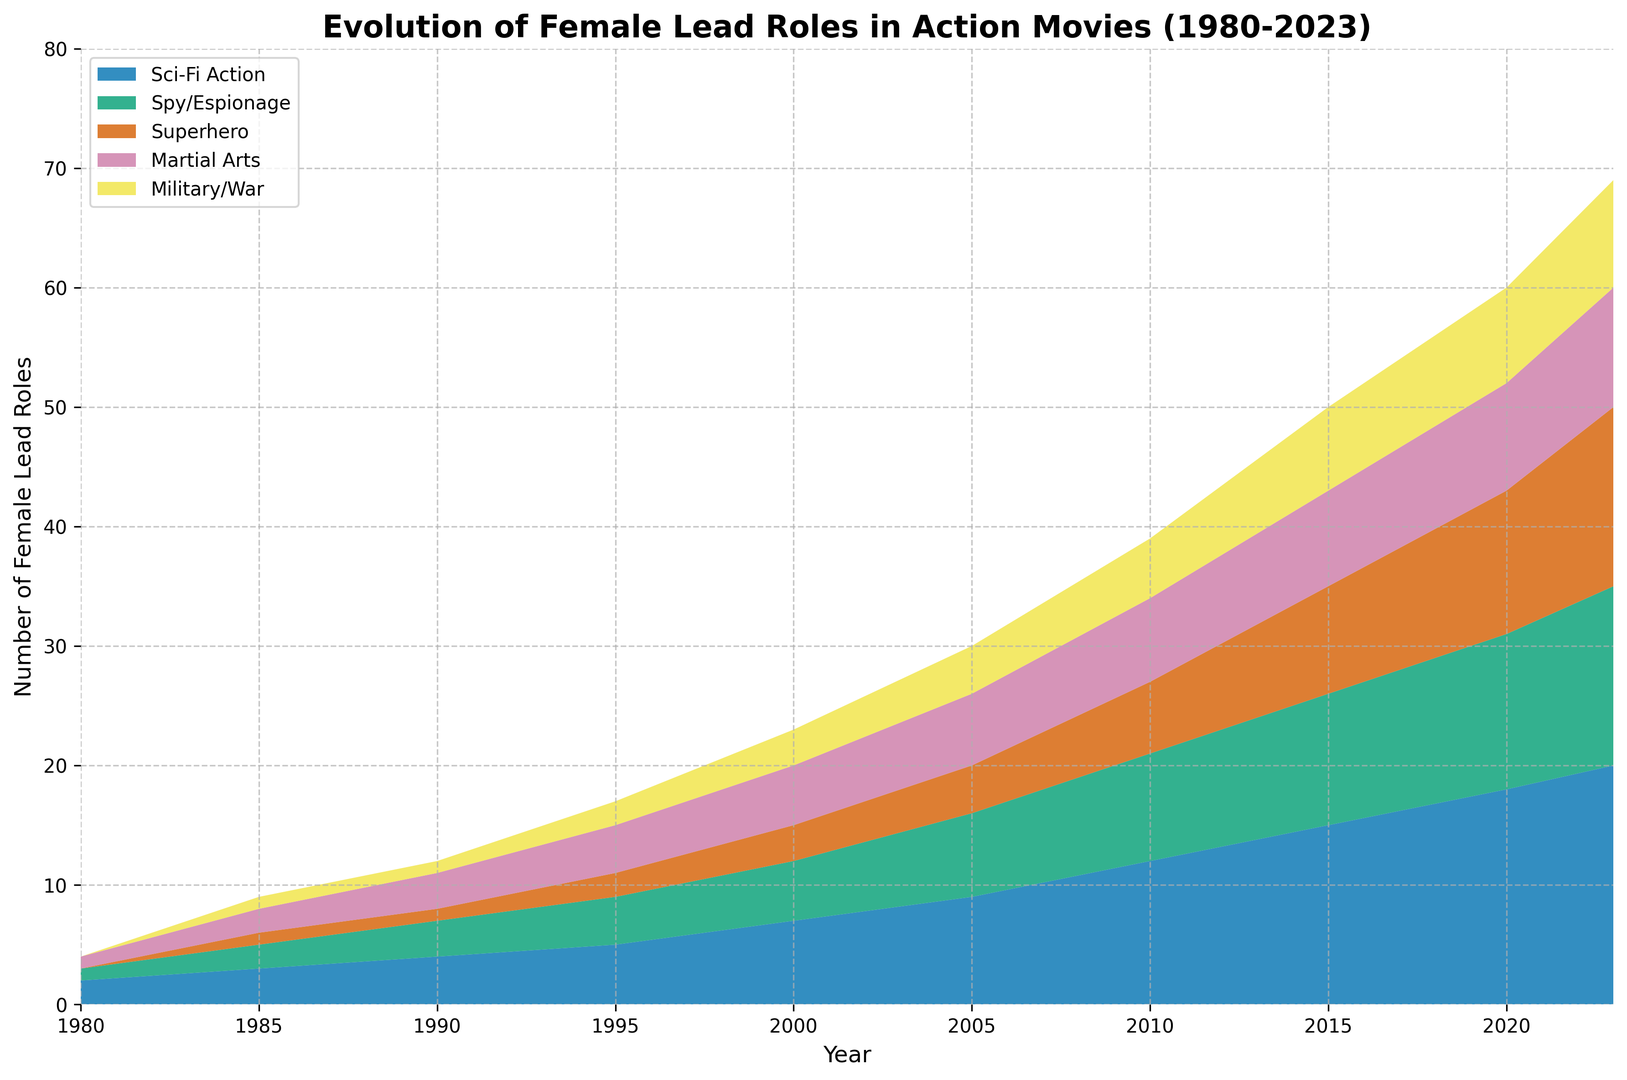What's the subgenre with the highest number of female lead roles in 2020? To answer this, we simply look at the heights of areas in the area chart for the year 2020 and compare them. The Sci-Fi Action section is the tallest, representing the highest number of female lead roles in 2020.
Answer: Sci-Fi Action Which subgenre saw the steepest increase in female lead roles from 1980 to 2023? To determine this, observe the gradient or slope of the areas from 1980 to 2023. The Sci-Fi Action section shows the steepest increase as it expanded the most relative to other subgenres.
Answer: Sci-Fi Action In which year did Martial Arts movies have exactly 7 female lead roles? Find the point where the area corresponding to Martial Arts movies reaches 7 on the vertical axis. This happens in the year 2010.
Answer: 2010 What is the combined total of female lead roles in all subgenres in 1985? For this, sum the values for each subgenre in 1985: 3 (Sci-Fi Action) + 2 (Spy/Espionage) + 1 (Superhero) + 2 (Martial Arts) + 1 (Military/War). This totals to 9.
Answer: 9 How many more female lead roles are there in Superhero movies in 2023 compared to 1995? Subtract the number of female lead roles in 1995 from the number in 2023 for Superhero movies: 15 (in 2023) - 2 (in 1995) = 13.
Answer: 13 Which two subgenres had equal numbers of female lead roles in 2005? Look at the heights of the sections in 2005. Spy/Espionage and Martial Arts both had 6 female lead roles.
Answer: Spy/Espionage and Martial Arts What's the average number of female lead roles across all subgenres in 2000? Sum the values for each subgenre in 2000: 7 (Sci-Fi Action) + 5 (Spy/Espionage) + 3 (Superhero) + 5 (Martial Arts) + 3 (Military/War) = 23. The average is 23/5 = 4.6.
Answer: 4.6 Between which two years did Military/War movies see the largest increase in female lead roles? Compare the heights year by year for Military/War. The largest increase occurs between 2005 (4) and 2010 (5), which is an increase of 1.
Answer: 2005 and 2010 What subgenre had the fewest female lead roles in 1990? Compare the heights of all subgenres for 1990. Superhero movies had the fewest female lead roles with just 1.
Answer: Superhero 